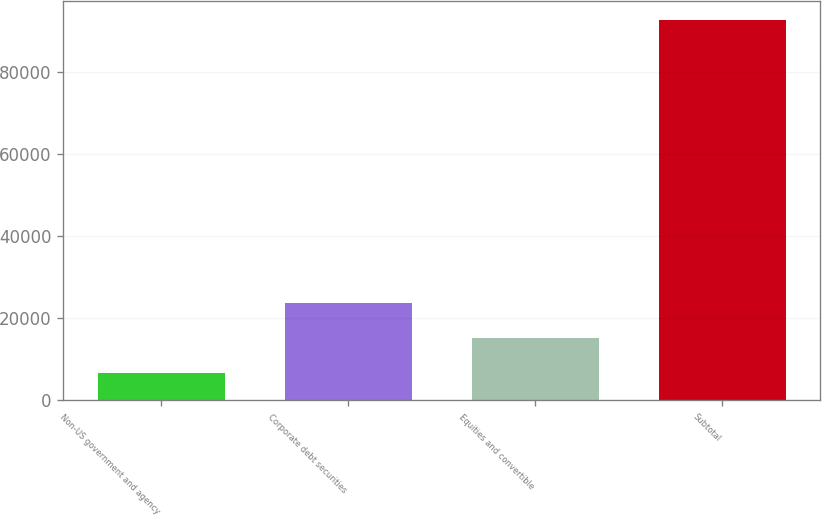Convert chart. <chart><loc_0><loc_0><loc_500><loc_500><bar_chart><fcel>Non-US government and agency<fcel>Corporate debt securities<fcel>Equities and convertible<fcel>Subtotal<nl><fcel>6668<fcel>23874.4<fcel>15271.2<fcel>92700<nl></chart> 